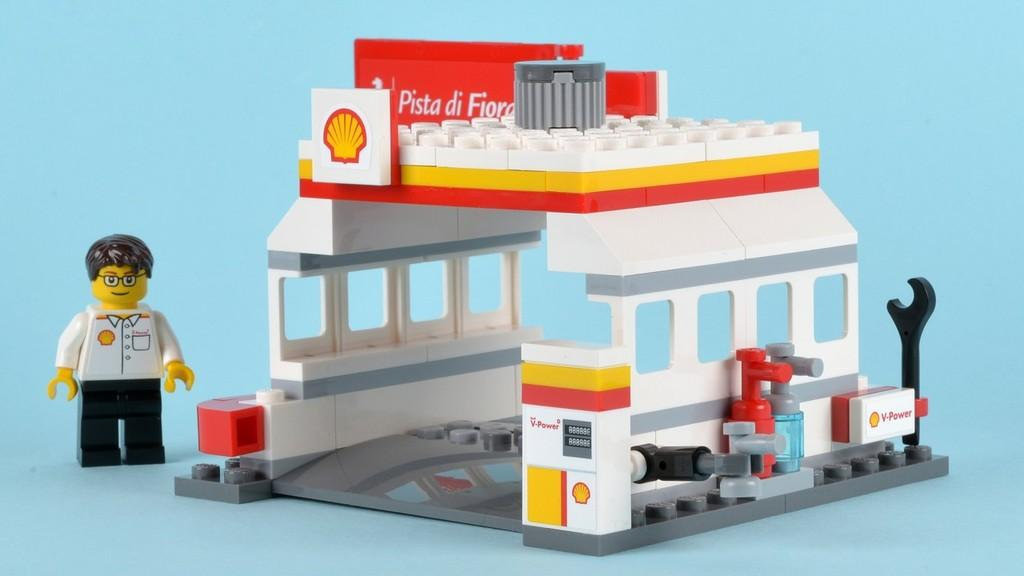What type of Lego structure is in the image? There is a Lego shell station in the image. Can you describe the toy person in the image? There is a toy person on the left side of the image. What type of skin condition does the toy person have in the image? There is no indication of a skin condition in the image, as it features a Lego shell station and a toy person. 